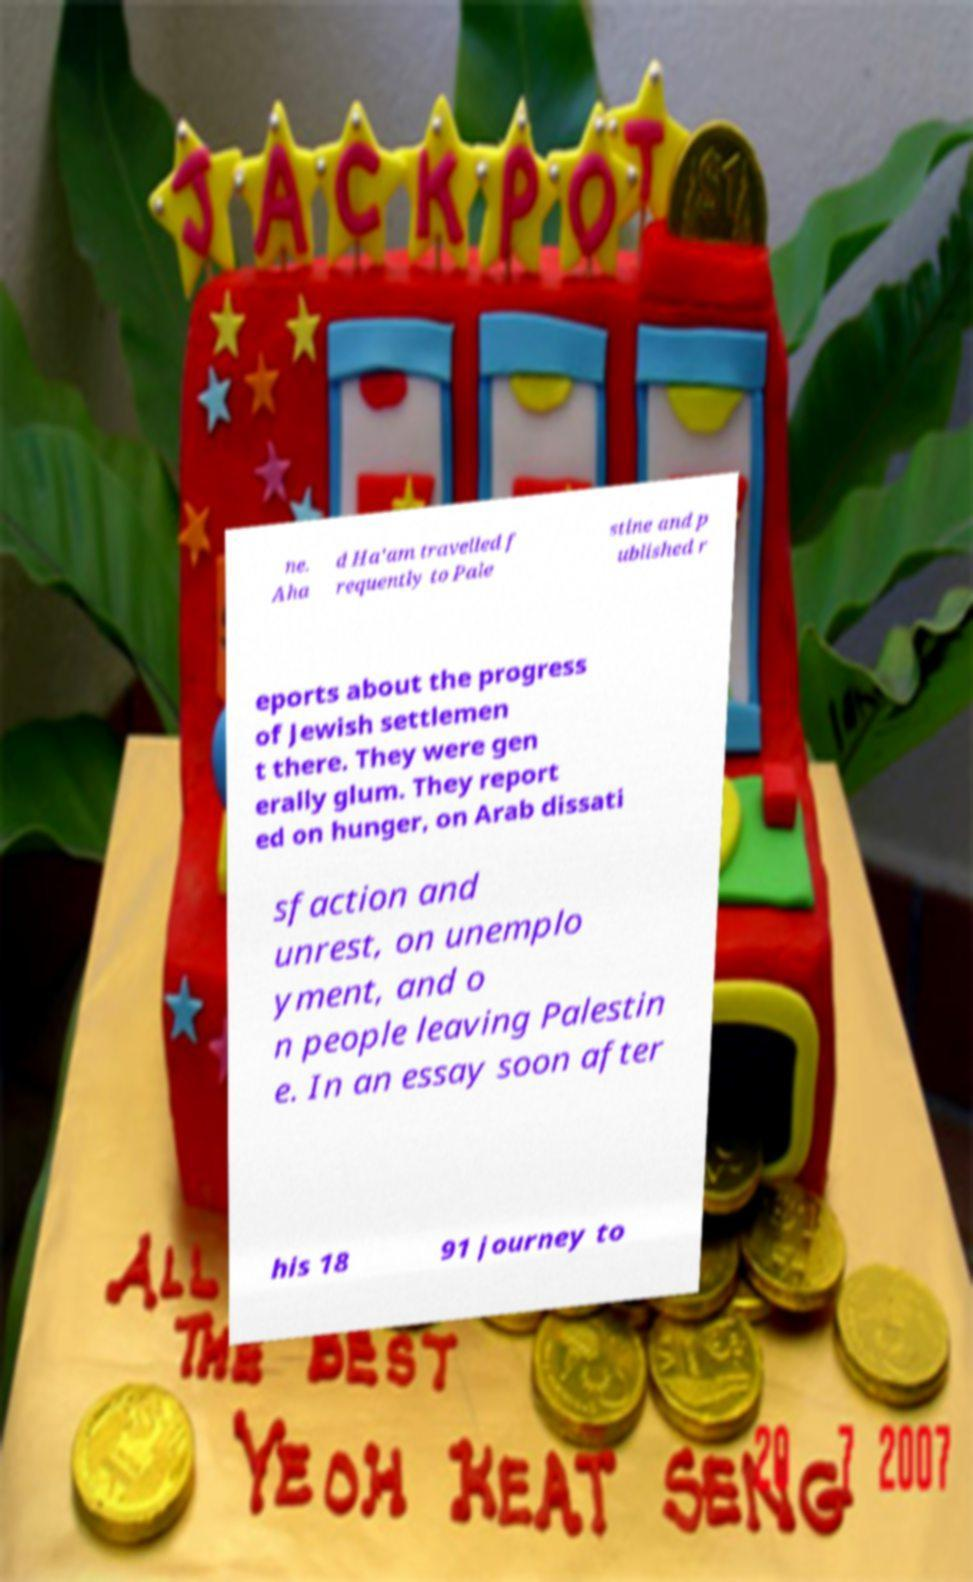There's text embedded in this image that I need extracted. Can you transcribe it verbatim? ne. Aha d Ha'am travelled f requently to Pale stine and p ublished r eports about the progress of Jewish settlemen t there. They were gen erally glum. They report ed on hunger, on Arab dissati sfaction and unrest, on unemplo yment, and o n people leaving Palestin e. In an essay soon after his 18 91 journey to 